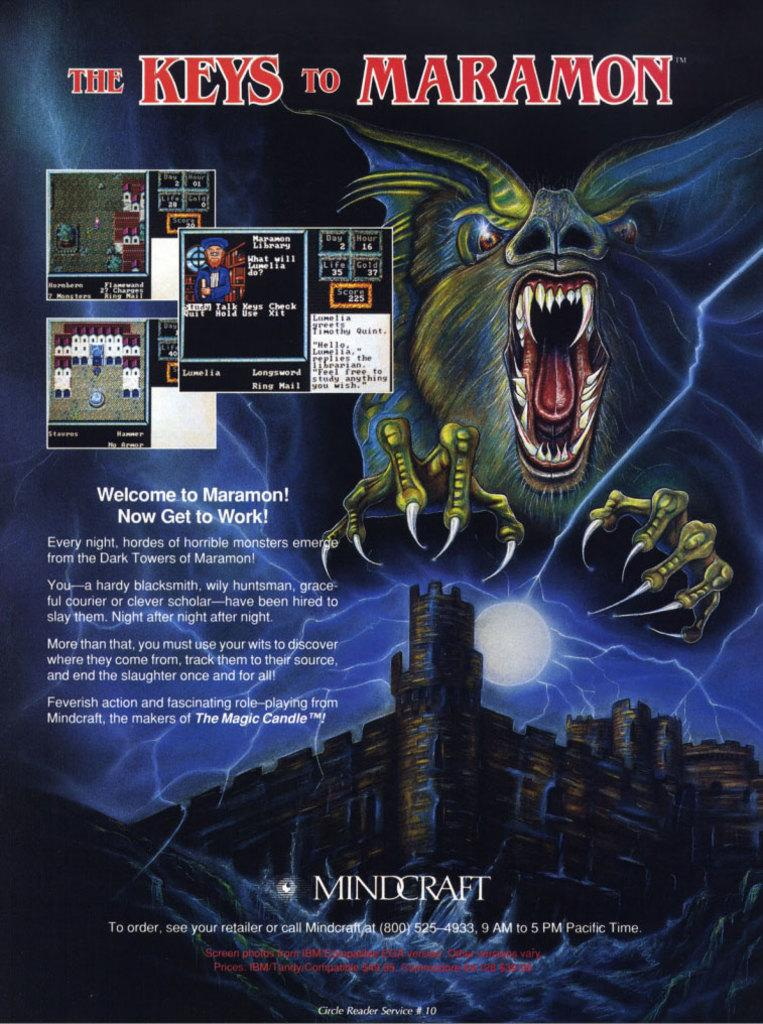<image>
Provide a brief description of the given image. A poster about a game called The Keys to Maramon by Mindcraft. 